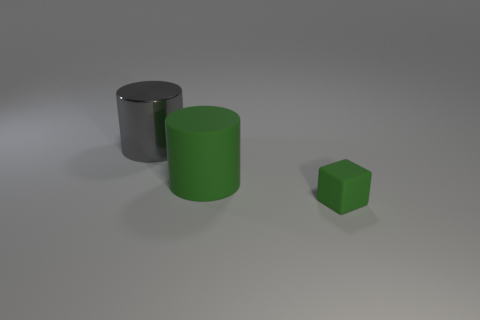Add 1 small green objects. How many objects exist? 4 Subtract all green cylinders. Subtract all green cubes. How many cylinders are left? 1 Subtract all cubes. How many objects are left? 2 Subtract 0 brown spheres. How many objects are left? 3 Subtract all green cylinders. Subtract all large shiny cylinders. How many objects are left? 1 Add 1 tiny green matte blocks. How many tiny green matte blocks are left? 2 Add 2 gray cubes. How many gray cubes exist? 2 